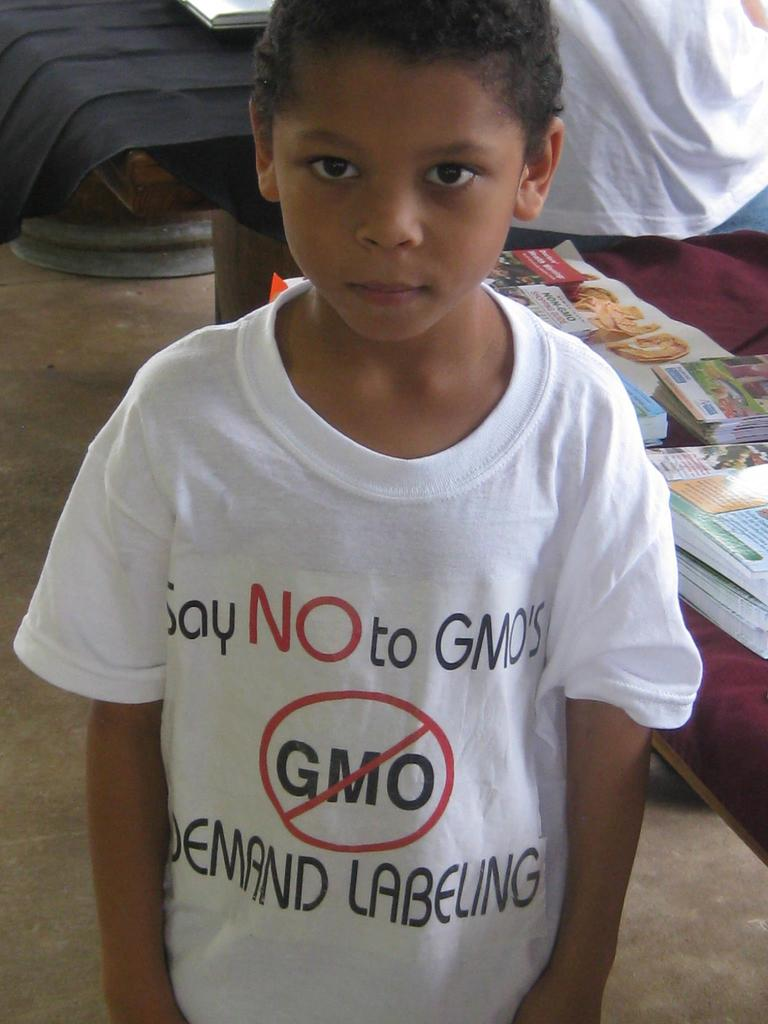What is: Who is the main subject in the image? There is a boy in the image. What can be seen in the background of the image? There are books in the background of the image. How many frogs are sitting on the boy's head in the image? There are no frogs present in the image, so it is not possible to determine how many might be sitting on the boy's head. 